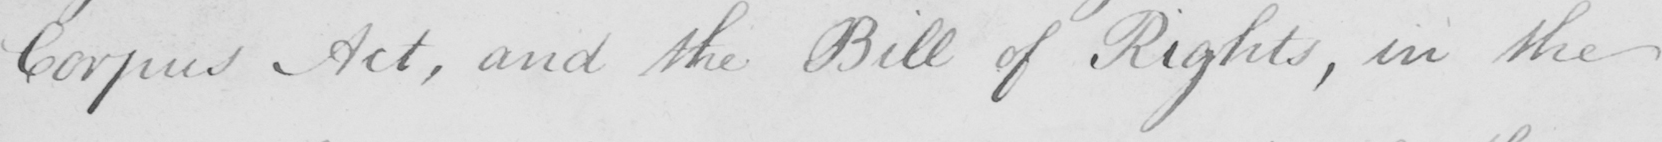Can you read and transcribe this handwriting? Corpus Act , and the Bill of Rights , in the 